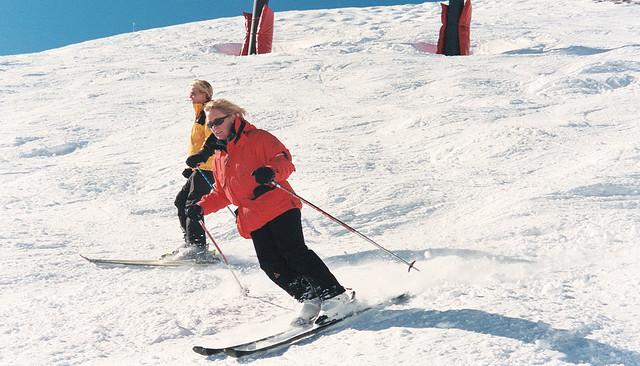Is this ski lesson going well?
Give a very brief answer. Yes. How many poles are sticking out the ground?
Concise answer only. 2. Is the lady in the red coat wearing sunglasses?
Give a very brief answer. Yes. What is cast?
Short answer required. Shadow. How many people are in this picture?
Answer briefly. 2. 